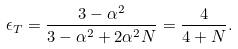Convert formula to latex. <formula><loc_0><loc_0><loc_500><loc_500>\epsilon _ { T } = \frac { 3 - \alpha ^ { 2 } } { 3 - \alpha ^ { 2 } + 2 \alpha ^ { 2 } N } = \frac { 4 } { 4 + N } .</formula> 